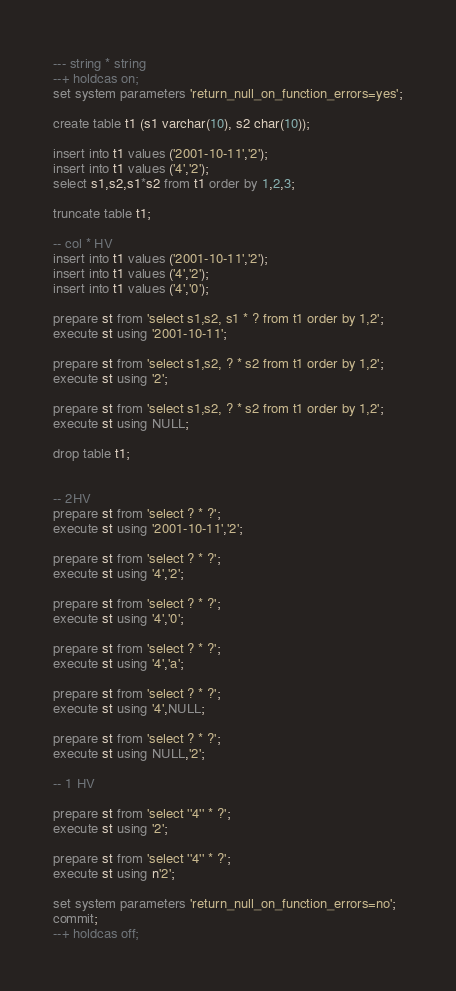Convert code to text. <code><loc_0><loc_0><loc_500><loc_500><_SQL_>--- string * string
--+ holdcas on;
set system parameters 'return_null_on_function_errors=yes';

create table t1 (s1 varchar(10), s2 char(10));

insert into t1 values ('2001-10-11','2');
insert into t1 values ('4','2');
select s1,s2,s1*s2 from t1 order by 1,2,3;

truncate table t1;

-- col * HV
insert into t1 values ('2001-10-11','2');
insert into t1 values ('4','2');
insert into t1 values ('4','0');

prepare st from 'select s1,s2, s1 * ? from t1 order by 1,2';
execute st using '2001-10-11';

prepare st from 'select s1,s2, ? * s2 from t1 order by 1,2';
execute st using '2';

prepare st from 'select s1,s2, ? * s2 from t1 order by 1,2';
execute st using NULL;

drop table t1;


-- 2HV
prepare st from 'select ? * ?';
execute st using '2001-10-11','2';

prepare st from 'select ? * ?';
execute st using '4','2';

prepare st from 'select ? * ?';
execute st using '4','0';

prepare st from 'select ? * ?';
execute st using '4','a';

prepare st from 'select ? * ?';
execute st using '4',NULL;

prepare st from 'select ? * ?';
execute st using NULL,'2';

-- 1 HV

prepare st from 'select ''4'' * ?';
execute st using '2';

prepare st from 'select ''4'' * ?';
execute st using n'2';

set system parameters 'return_null_on_function_errors=no';
commit;
--+ holdcas off;
</code> 